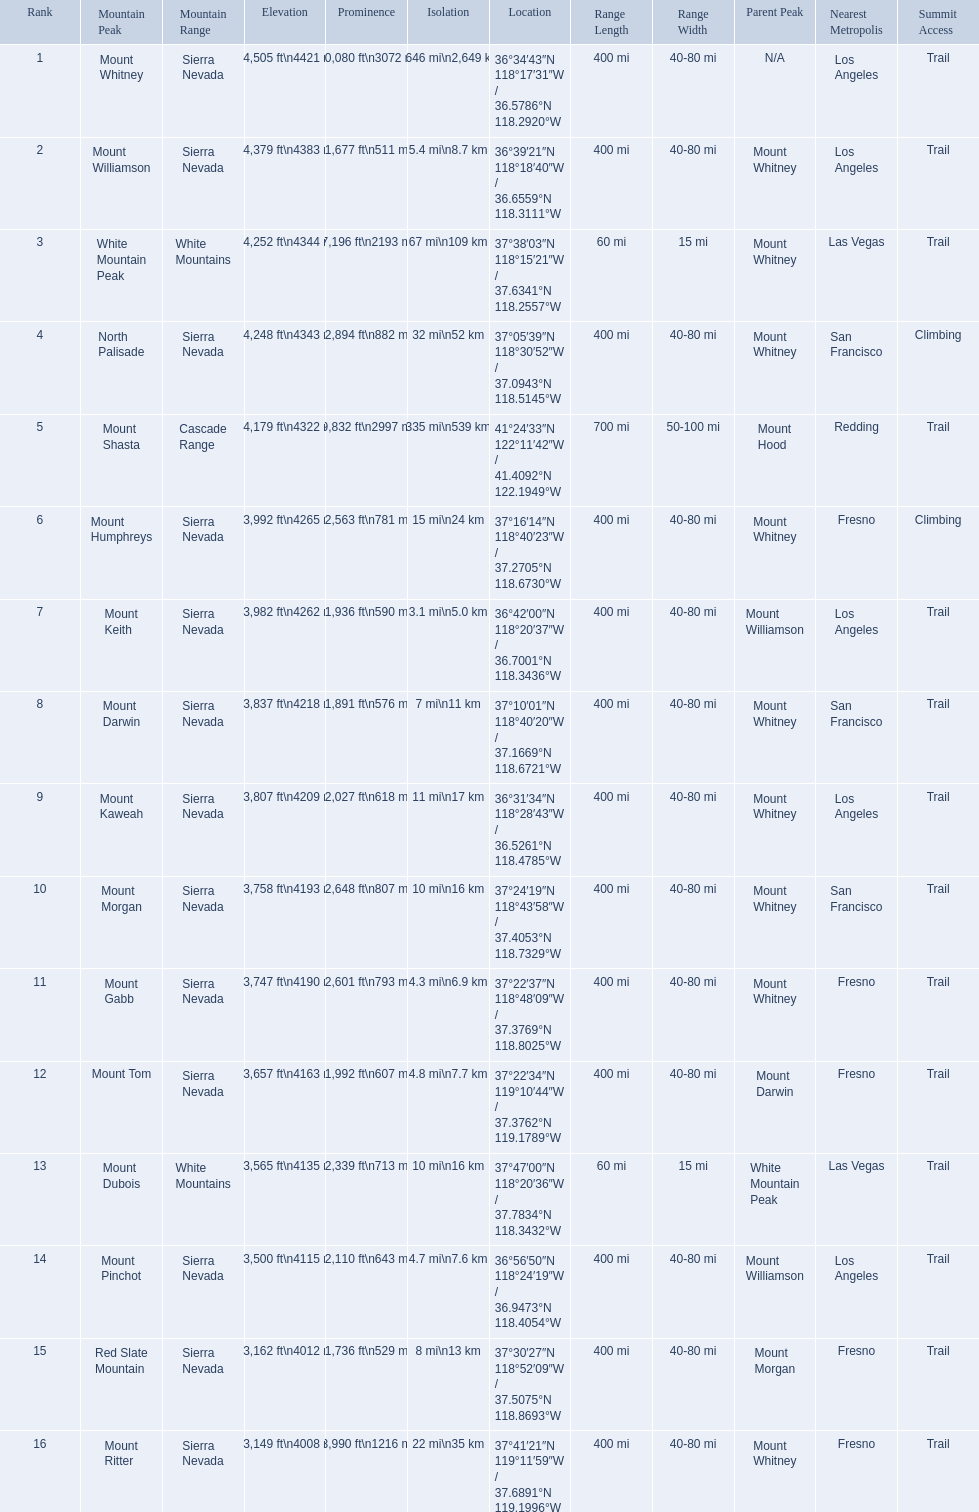Which mountain peak is in the white mountains range? White Mountain Peak. Which mountain is in the sierra nevada range? Mount Whitney. Which mountain is the only one in the cascade range? Mount Shasta. What are all of the mountain peaks? Mount Whitney, Mount Williamson, White Mountain Peak, North Palisade, Mount Shasta, Mount Humphreys, Mount Keith, Mount Darwin, Mount Kaweah, Mount Morgan, Mount Gabb, Mount Tom, Mount Dubois, Mount Pinchot, Red Slate Mountain, Mount Ritter. In what ranges are they? Sierra Nevada, Sierra Nevada, White Mountains, Sierra Nevada, Cascade Range, Sierra Nevada, Sierra Nevada, Sierra Nevada, Sierra Nevada, Sierra Nevada, Sierra Nevada, Sierra Nevada, White Mountains, Sierra Nevada, Sierra Nevada, Sierra Nevada. Which peak is in the cascade range? Mount Shasta. What are the mountain peaks? Mount Whitney, Mount Williamson, White Mountain Peak, North Palisade, Mount Shasta, Mount Humphreys, Mount Keith, Mount Darwin, Mount Kaweah, Mount Morgan, Mount Gabb, Mount Tom, Mount Dubois, Mount Pinchot, Red Slate Mountain, Mount Ritter. Of these, which one has a prominence more than 10,000 ft? Mount Whitney. 